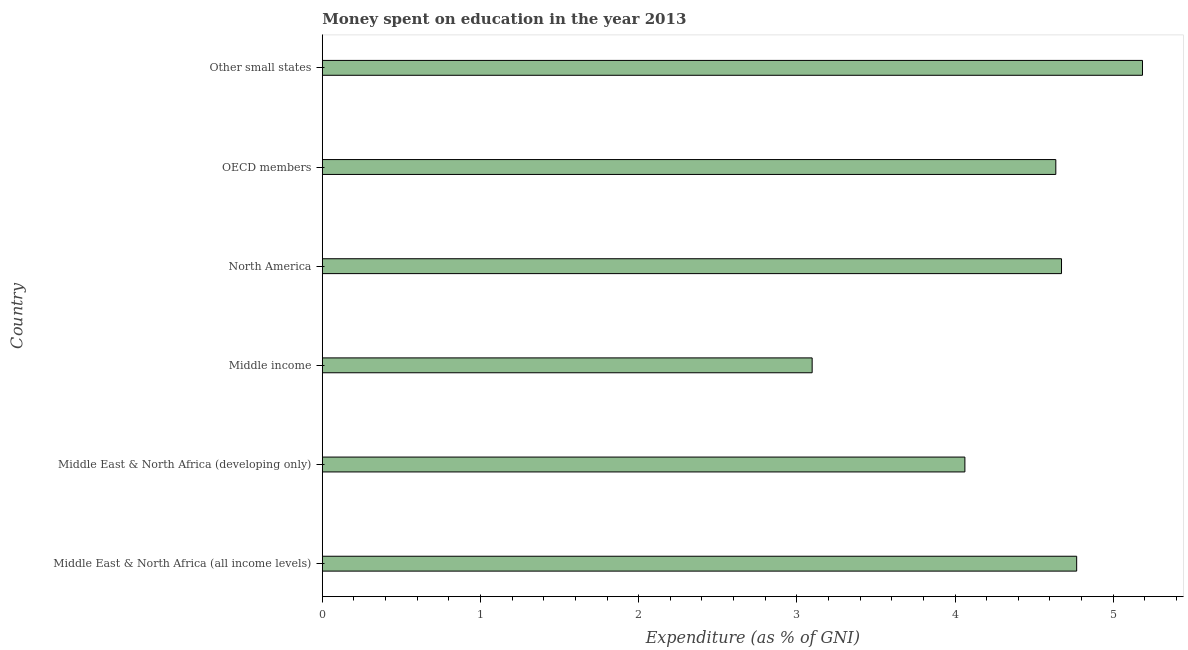Does the graph contain any zero values?
Your response must be concise. No. Does the graph contain grids?
Offer a very short reply. No. What is the title of the graph?
Keep it short and to the point. Money spent on education in the year 2013. What is the label or title of the X-axis?
Give a very brief answer. Expenditure (as % of GNI). What is the label or title of the Y-axis?
Provide a succinct answer. Country. What is the expenditure on education in Middle income?
Your response must be concise. 3.1. Across all countries, what is the maximum expenditure on education?
Your answer should be very brief. 5.18. Across all countries, what is the minimum expenditure on education?
Your answer should be very brief. 3.1. In which country was the expenditure on education maximum?
Ensure brevity in your answer.  Other small states. What is the sum of the expenditure on education?
Your response must be concise. 26.42. What is the difference between the expenditure on education in North America and OECD members?
Make the answer very short. 0.04. What is the average expenditure on education per country?
Provide a succinct answer. 4.4. What is the median expenditure on education?
Provide a succinct answer. 4.65. In how many countries, is the expenditure on education greater than 1 %?
Make the answer very short. 6. What is the ratio of the expenditure on education in Middle East & North Africa (developing only) to that in North America?
Ensure brevity in your answer.  0.87. What is the difference between the highest and the second highest expenditure on education?
Keep it short and to the point. 0.42. What is the difference between the highest and the lowest expenditure on education?
Keep it short and to the point. 2.09. How many bars are there?
Offer a terse response. 6. Are all the bars in the graph horizontal?
Make the answer very short. Yes. What is the difference between two consecutive major ticks on the X-axis?
Your answer should be compact. 1. Are the values on the major ticks of X-axis written in scientific E-notation?
Offer a terse response. No. What is the Expenditure (as % of GNI) of Middle East & North Africa (all income levels)?
Keep it short and to the point. 4.77. What is the Expenditure (as % of GNI) of Middle East & North Africa (developing only)?
Your response must be concise. 4.06. What is the Expenditure (as % of GNI) in Middle income?
Keep it short and to the point. 3.1. What is the Expenditure (as % of GNI) of North America?
Your answer should be compact. 4.67. What is the Expenditure (as % of GNI) in OECD members?
Offer a terse response. 4.64. What is the Expenditure (as % of GNI) of Other small states?
Ensure brevity in your answer.  5.18. What is the difference between the Expenditure (as % of GNI) in Middle East & North Africa (all income levels) and Middle East & North Africa (developing only)?
Provide a succinct answer. 0.71. What is the difference between the Expenditure (as % of GNI) in Middle East & North Africa (all income levels) and Middle income?
Your answer should be very brief. 1.67. What is the difference between the Expenditure (as % of GNI) in Middle East & North Africa (all income levels) and North America?
Make the answer very short. 0.1. What is the difference between the Expenditure (as % of GNI) in Middle East & North Africa (all income levels) and OECD members?
Your answer should be very brief. 0.13. What is the difference between the Expenditure (as % of GNI) in Middle East & North Africa (all income levels) and Other small states?
Offer a terse response. -0.42. What is the difference between the Expenditure (as % of GNI) in Middle East & North Africa (developing only) and Middle income?
Provide a succinct answer. 0.97. What is the difference between the Expenditure (as % of GNI) in Middle East & North Africa (developing only) and North America?
Offer a very short reply. -0.61. What is the difference between the Expenditure (as % of GNI) in Middle East & North Africa (developing only) and OECD members?
Offer a terse response. -0.57. What is the difference between the Expenditure (as % of GNI) in Middle East & North Africa (developing only) and Other small states?
Your answer should be compact. -1.12. What is the difference between the Expenditure (as % of GNI) in Middle income and North America?
Provide a short and direct response. -1.58. What is the difference between the Expenditure (as % of GNI) in Middle income and OECD members?
Provide a short and direct response. -1.54. What is the difference between the Expenditure (as % of GNI) in Middle income and Other small states?
Provide a short and direct response. -2.09. What is the difference between the Expenditure (as % of GNI) in North America and OECD members?
Make the answer very short. 0.04. What is the difference between the Expenditure (as % of GNI) in North America and Other small states?
Your response must be concise. -0.51. What is the difference between the Expenditure (as % of GNI) in OECD members and Other small states?
Ensure brevity in your answer.  -0.55. What is the ratio of the Expenditure (as % of GNI) in Middle East & North Africa (all income levels) to that in Middle East & North Africa (developing only)?
Offer a terse response. 1.17. What is the ratio of the Expenditure (as % of GNI) in Middle East & North Africa (all income levels) to that in Middle income?
Offer a very short reply. 1.54. What is the ratio of the Expenditure (as % of GNI) in Middle East & North Africa (all income levels) to that in OECD members?
Your answer should be compact. 1.03. What is the ratio of the Expenditure (as % of GNI) in Middle East & North Africa (developing only) to that in Middle income?
Provide a short and direct response. 1.31. What is the ratio of the Expenditure (as % of GNI) in Middle East & North Africa (developing only) to that in North America?
Provide a short and direct response. 0.87. What is the ratio of the Expenditure (as % of GNI) in Middle East & North Africa (developing only) to that in OECD members?
Your answer should be very brief. 0.88. What is the ratio of the Expenditure (as % of GNI) in Middle East & North Africa (developing only) to that in Other small states?
Make the answer very short. 0.78. What is the ratio of the Expenditure (as % of GNI) in Middle income to that in North America?
Offer a terse response. 0.66. What is the ratio of the Expenditure (as % of GNI) in Middle income to that in OECD members?
Give a very brief answer. 0.67. What is the ratio of the Expenditure (as % of GNI) in Middle income to that in Other small states?
Offer a terse response. 0.6. What is the ratio of the Expenditure (as % of GNI) in North America to that in Other small states?
Give a very brief answer. 0.9. What is the ratio of the Expenditure (as % of GNI) in OECD members to that in Other small states?
Provide a succinct answer. 0.89. 